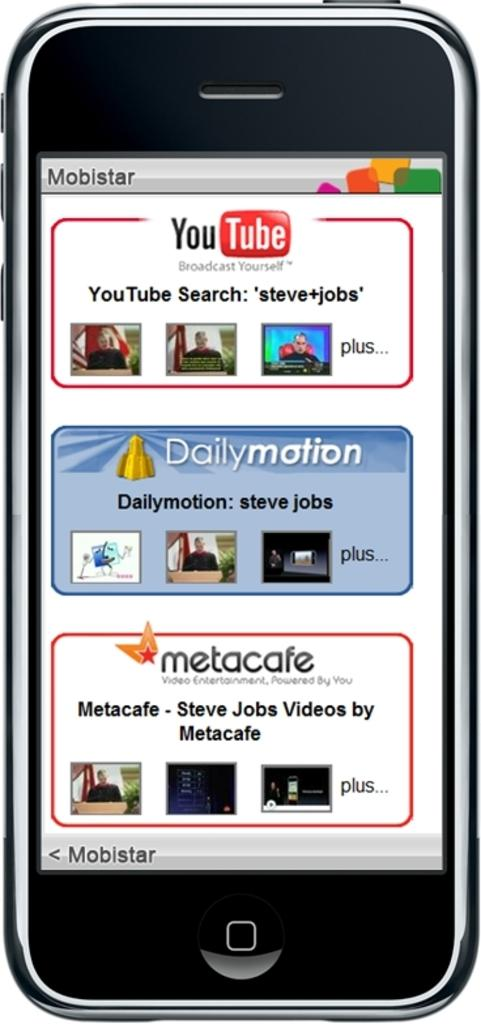Provide a one-sentence caption for the provided image. a smart phone with a tab for daily motion in the middle. 